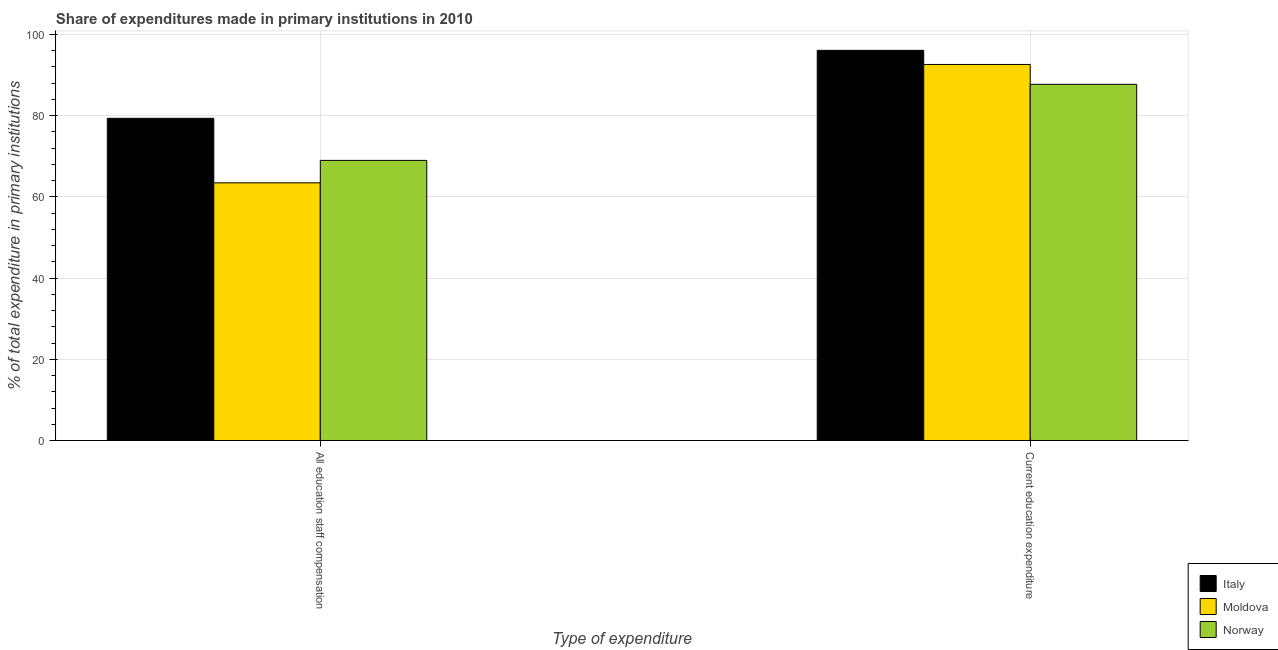How many different coloured bars are there?
Provide a short and direct response. 3. How many groups of bars are there?
Your answer should be compact. 2. Are the number of bars per tick equal to the number of legend labels?
Ensure brevity in your answer.  Yes. Are the number of bars on each tick of the X-axis equal?
Ensure brevity in your answer.  Yes. What is the label of the 2nd group of bars from the left?
Make the answer very short. Current education expenditure. What is the expenditure in staff compensation in Italy?
Provide a succinct answer. 79.33. Across all countries, what is the maximum expenditure in staff compensation?
Provide a short and direct response. 79.33. Across all countries, what is the minimum expenditure in education?
Ensure brevity in your answer.  87.7. In which country was the expenditure in education minimum?
Your response must be concise. Norway. What is the total expenditure in education in the graph?
Provide a succinct answer. 276.35. What is the difference between the expenditure in education in Moldova and that in Italy?
Your response must be concise. -3.48. What is the difference between the expenditure in staff compensation in Moldova and the expenditure in education in Italy?
Give a very brief answer. -32.62. What is the average expenditure in education per country?
Offer a terse response. 92.12. What is the difference between the expenditure in education and expenditure in staff compensation in Norway?
Give a very brief answer. 18.73. In how many countries, is the expenditure in education greater than 16 %?
Offer a terse response. 3. What is the ratio of the expenditure in staff compensation in Moldova to that in Norway?
Offer a very short reply. 0.92. Is the expenditure in education in Norway less than that in Moldova?
Give a very brief answer. Yes. What does the 2nd bar from the left in All education staff compensation represents?
Make the answer very short. Moldova. What does the 3rd bar from the right in All education staff compensation represents?
Your response must be concise. Italy. How many bars are there?
Offer a terse response. 6. What is the difference between two consecutive major ticks on the Y-axis?
Offer a terse response. 20. Does the graph contain any zero values?
Keep it short and to the point. No. Does the graph contain grids?
Your response must be concise. Yes. Where does the legend appear in the graph?
Your answer should be compact. Bottom right. What is the title of the graph?
Offer a very short reply. Share of expenditures made in primary institutions in 2010. Does "Madagascar" appear as one of the legend labels in the graph?
Your response must be concise. No. What is the label or title of the X-axis?
Provide a succinct answer. Type of expenditure. What is the label or title of the Y-axis?
Offer a terse response. % of total expenditure in primary institutions. What is the % of total expenditure in primary institutions in Italy in All education staff compensation?
Keep it short and to the point. 79.33. What is the % of total expenditure in primary institutions of Moldova in All education staff compensation?
Offer a terse response. 63.45. What is the % of total expenditure in primary institutions in Norway in All education staff compensation?
Your response must be concise. 68.97. What is the % of total expenditure in primary institutions of Italy in Current education expenditure?
Your answer should be compact. 96.07. What is the % of total expenditure in primary institutions of Moldova in Current education expenditure?
Your answer should be compact. 92.59. What is the % of total expenditure in primary institutions of Norway in Current education expenditure?
Provide a short and direct response. 87.7. Across all Type of expenditure, what is the maximum % of total expenditure in primary institutions of Italy?
Offer a terse response. 96.07. Across all Type of expenditure, what is the maximum % of total expenditure in primary institutions of Moldova?
Offer a terse response. 92.59. Across all Type of expenditure, what is the maximum % of total expenditure in primary institutions in Norway?
Provide a short and direct response. 87.7. Across all Type of expenditure, what is the minimum % of total expenditure in primary institutions in Italy?
Give a very brief answer. 79.33. Across all Type of expenditure, what is the minimum % of total expenditure in primary institutions in Moldova?
Keep it short and to the point. 63.45. Across all Type of expenditure, what is the minimum % of total expenditure in primary institutions of Norway?
Offer a terse response. 68.97. What is the total % of total expenditure in primary institutions in Italy in the graph?
Make the answer very short. 175.4. What is the total % of total expenditure in primary institutions in Moldova in the graph?
Your answer should be compact. 156.04. What is the total % of total expenditure in primary institutions in Norway in the graph?
Ensure brevity in your answer.  156.67. What is the difference between the % of total expenditure in primary institutions of Italy in All education staff compensation and that in Current education expenditure?
Offer a very short reply. -16.73. What is the difference between the % of total expenditure in primary institutions in Moldova in All education staff compensation and that in Current education expenditure?
Your answer should be very brief. -29.14. What is the difference between the % of total expenditure in primary institutions of Norway in All education staff compensation and that in Current education expenditure?
Your response must be concise. -18.73. What is the difference between the % of total expenditure in primary institutions of Italy in All education staff compensation and the % of total expenditure in primary institutions of Moldova in Current education expenditure?
Make the answer very short. -13.26. What is the difference between the % of total expenditure in primary institutions of Italy in All education staff compensation and the % of total expenditure in primary institutions of Norway in Current education expenditure?
Your response must be concise. -8.37. What is the difference between the % of total expenditure in primary institutions of Moldova in All education staff compensation and the % of total expenditure in primary institutions of Norway in Current education expenditure?
Your response must be concise. -24.25. What is the average % of total expenditure in primary institutions of Italy per Type of expenditure?
Provide a succinct answer. 87.7. What is the average % of total expenditure in primary institutions of Moldova per Type of expenditure?
Provide a short and direct response. 78.02. What is the average % of total expenditure in primary institutions of Norway per Type of expenditure?
Give a very brief answer. 78.34. What is the difference between the % of total expenditure in primary institutions of Italy and % of total expenditure in primary institutions of Moldova in All education staff compensation?
Offer a terse response. 15.89. What is the difference between the % of total expenditure in primary institutions of Italy and % of total expenditure in primary institutions of Norway in All education staff compensation?
Give a very brief answer. 10.36. What is the difference between the % of total expenditure in primary institutions of Moldova and % of total expenditure in primary institutions of Norway in All education staff compensation?
Ensure brevity in your answer.  -5.52. What is the difference between the % of total expenditure in primary institutions in Italy and % of total expenditure in primary institutions in Moldova in Current education expenditure?
Keep it short and to the point. 3.48. What is the difference between the % of total expenditure in primary institutions in Italy and % of total expenditure in primary institutions in Norway in Current education expenditure?
Make the answer very short. 8.37. What is the difference between the % of total expenditure in primary institutions in Moldova and % of total expenditure in primary institutions in Norway in Current education expenditure?
Make the answer very short. 4.89. What is the ratio of the % of total expenditure in primary institutions in Italy in All education staff compensation to that in Current education expenditure?
Provide a short and direct response. 0.83. What is the ratio of the % of total expenditure in primary institutions in Moldova in All education staff compensation to that in Current education expenditure?
Offer a very short reply. 0.69. What is the ratio of the % of total expenditure in primary institutions in Norway in All education staff compensation to that in Current education expenditure?
Offer a very short reply. 0.79. What is the difference between the highest and the second highest % of total expenditure in primary institutions of Italy?
Your response must be concise. 16.73. What is the difference between the highest and the second highest % of total expenditure in primary institutions of Moldova?
Make the answer very short. 29.14. What is the difference between the highest and the second highest % of total expenditure in primary institutions of Norway?
Your answer should be compact. 18.73. What is the difference between the highest and the lowest % of total expenditure in primary institutions in Italy?
Offer a very short reply. 16.73. What is the difference between the highest and the lowest % of total expenditure in primary institutions of Moldova?
Keep it short and to the point. 29.14. What is the difference between the highest and the lowest % of total expenditure in primary institutions in Norway?
Your answer should be compact. 18.73. 